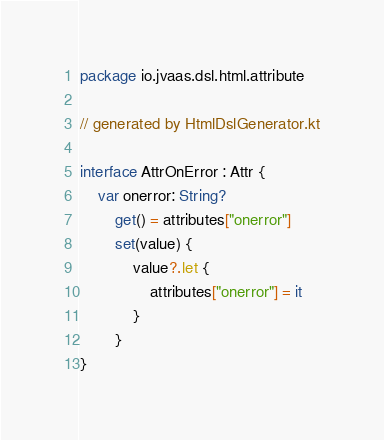<code> <loc_0><loc_0><loc_500><loc_500><_Kotlin_>package io.jvaas.dsl.html.attribute

// generated by HtmlDslGenerator.kt

interface AttrOnError : Attr {
	var onerror: String?
		get() = attributes["onerror"]
		set(value) {
			value?.let {
				attributes["onerror"] = it
			}
		}
}	
</code> 